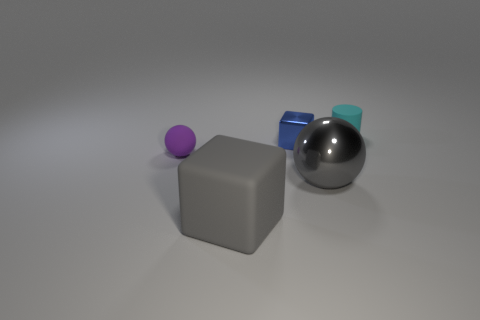Is the size of the ball that is to the right of the shiny cube the same as the object in front of the gray metal sphere?
Your answer should be compact. Yes. What number of big blue things are the same material as the tiny blue object?
Ensure brevity in your answer.  0. What color is the shiny ball?
Your answer should be compact. Gray. Are there any balls behind the cyan matte thing?
Ensure brevity in your answer.  No. Do the tiny matte cylinder and the small shiny thing have the same color?
Ensure brevity in your answer.  No. How many large balls are the same color as the tiny shiny thing?
Provide a succinct answer. 0. What is the size of the gray object on the right side of the gray thing that is left of the blue metal object?
Make the answer very short. Large. There is a cyan thing; what shape is it?
Offer a very short reply. Cylinder. What material is the large object that is behind the big gray cube?
Your answer should be compact. Metal. The thing that is in front of the large object to the right of the large thing to the left of the large shiny sphere is what color?
Make the answer very short. Gray. 